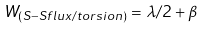Convert formula to latex. <formula><loc_0><loc_0><loc_500><loc_500>W _ { ( S - S f l u x / t o r s i o n ) } = \lambda / 2 + \beta \,</formula> 